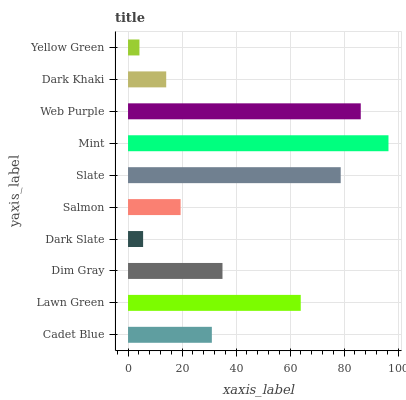Is Yellow Green the minimum?
Answer yes or no. Yes. Is Mint the maximum?
Answer yes or no. Yes. Is Lawn Green the minimum?
Answer yes or no. No. Is Lawn Green the maximum?
Answer yes or no. No. Is Lawn Green greater than Cadet Blue?
Answer yes or no. Yes. Is Cadet Blue less than Lawn Green?
Answer yes or no. Yes. Is Cadet Blue greater than Lawn Green?
Answer yes or no. No. Is Lawn Green less than Cadet Blue?
Answer yes or no. No. Is Dim Gray the high median?
Answer yes or no. Yes. Is Cadet Blue the low median?
Answer yes or no. Yes. Is Dark Slate the high median?
Answer yes or no. No. Is Dark Khaki the low median?
Answer yes or no. No. 